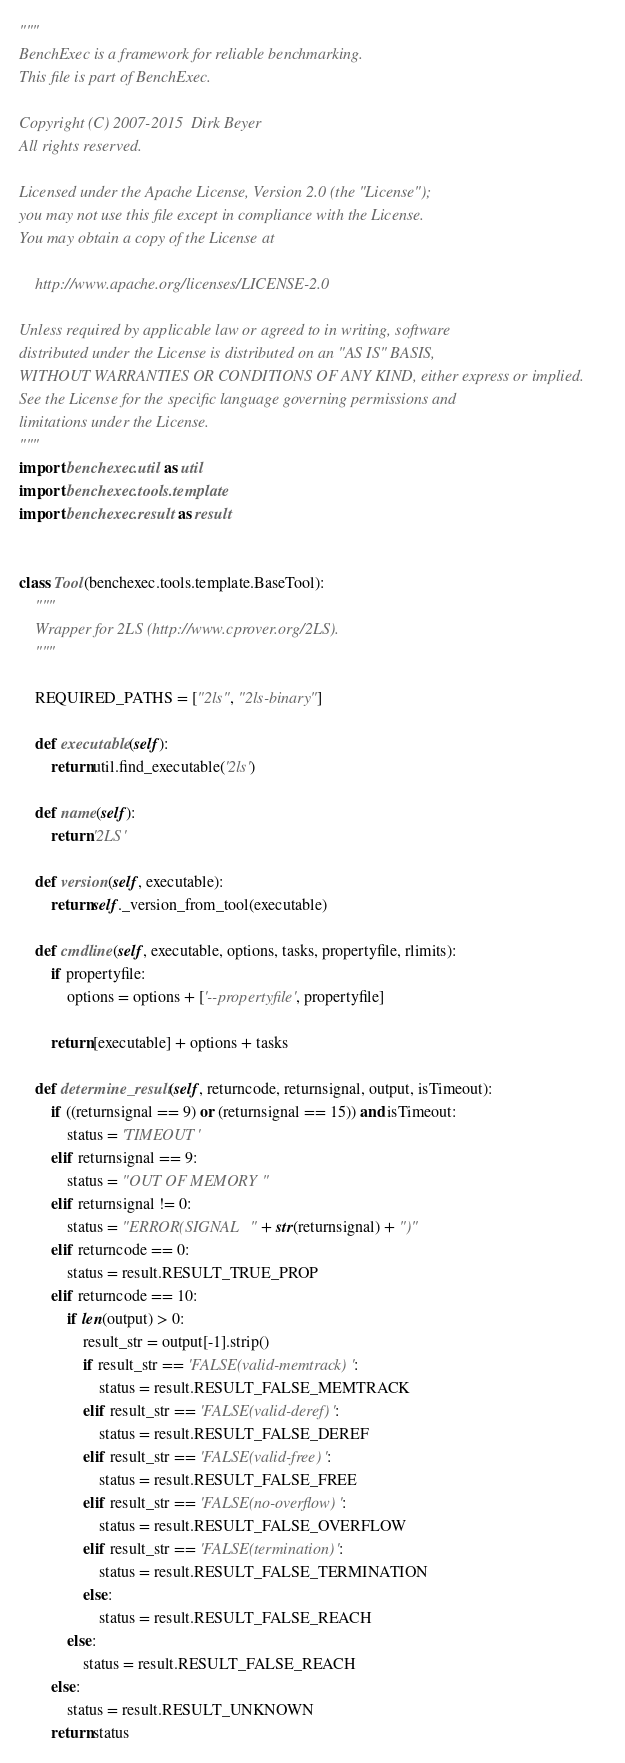<code> <loc_0><loc_0><loc_500><loc_500><_Python_>"""
BenchExec is a framework for reliable benchmarking.
This file is part of BenchExec.

Copyright (C) 2007-2015  Dirk Beyer
All rights reserved.

Licensed under the Apache License, Version 2.0 (the "License");
you may not use this file except in compliance with the License.
You may obtain a copy of the License at

    http://www.apache.org/licenses/LICENSE-2.0

Unless required by applicable law or agreed to in writing, software
distributed under the License is distributed on an "AS IS" BASIS,
WITHOUT WARRANTIES OR CONDITIONS OF ANY KIND, either express or implied.
See the License for the specific language governing permissions and
limitations under the License.
"""
import benchexec.util as util
import benchexec.tools.template
import benchexec.result as result


class Tool(benchexec.tools.template.BaseTool):
    """
    Wrapper for 2LS (http://www.cprover.org/2LS).
    """

    REQUIRED_PATHS = ["2ls", "2ls-binary"]

    def executable(self):
        return util.find_executable('2ls')

    def name(self):
        return '2LS'

    def version(self, executable):
        return self._version_from_tool(executable)

    def cmdline(self, executable, options, tasks, propertyfile, rlimits):
        if propertyfile:
            options = options + ['--propertyfile', propertyfile]

        return [executable] + options + tasks

    def determine_result(self, returncode, returnsignal, output, isTimeout):
        if ((returnsignal == 9) or (returnsignal == 15)) and isTimeout:
            status = 'TIMEOUT'
        elif returnsignal == 9:
            status = "OUT OF MEMORY"
        elif returnsignal != 0:
            status = "ERROR(SIGNAL " + str(returnsignal) + ")"
        elif returncode == 0:
            status = result.RESULT_TRUE_PROP
        elif returncode == 10:
            if len(output) > 0:
                result_str = output[-1].strip()
                if result_str == 'FALSE(valid-memtrack)':
                    status = result.RESULT_FALSE_MEMTRACK
                elif result_str == 'FALSE(valid-deref)':
                    status = result.RESULT_FALSE_DEREF
                elif result_str == 'FALSE(valid-free)':
                    status = result.RESULT_FALSE_FREE
                elif result_str == 'FALSE(no-overflow)':
                    status = result.RESULT_FALSE_OVERFLOW
                elif result_str == 'FALSE(termination)':
                    status = result.RESULT_FALSE_TERMINATION
                else:
                    status = result.RESULT_FALSE_REACH
            else:
                status = result.RESULT_FALSE_REACH
        else:
            status = result.RESULT_UNKNOWN
        return status
</code> 